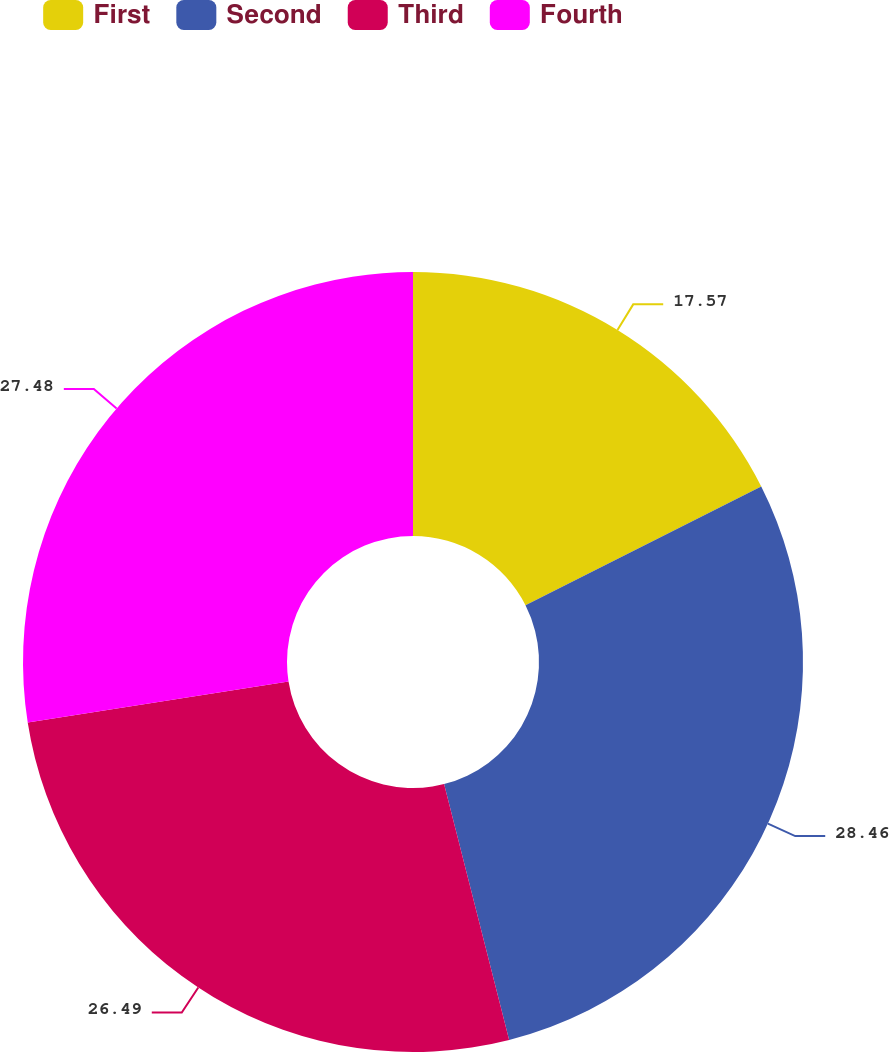Convert chart. <chart><loc_0><loc_0><loc_500><loc_500><pie_chart><fcel>First<fcel>Second<fcel>Third<fcel>Fourth<nl><fcel>17.57%<fcel>28.47%<fcel>26.49%<fcel>27.48%<nl></chart> 